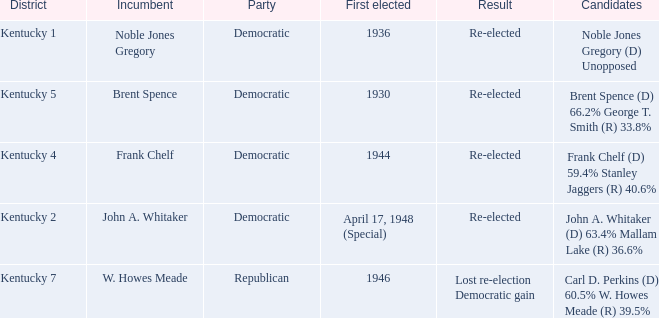Who were the candidates in the Kentucky 4 voting district? Frank Chelf (D) 59.4% Stanley Jaggers (R) 40.6%. 